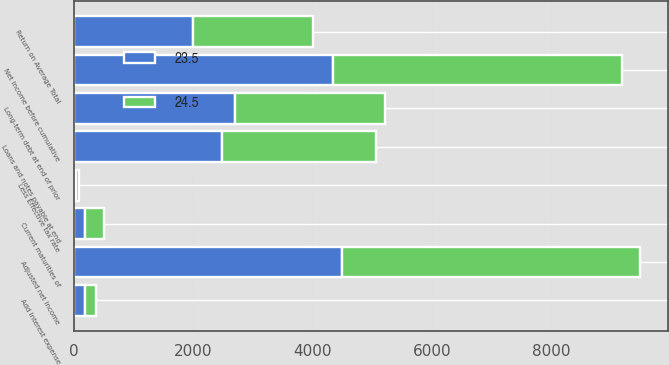Convert chart to OTSL. <chart><loc_0><loc_0><loc_500><loc_500><stacked_bar_chart><ecel><fcel>Return on Average Total<fcel>Net income before cumulative<fcel>Add Interest expense<fcel>Less Effective tax rate<fcel>Adjusted net income<fcel>Loans and notes payable at end<fcel>Current maturities of<fcel>Long-term debt at end of prior<nl><fcel>24.5<fcel>2004<fcel>4847<fcel>196<fcel>43<fcel>5000<fcel>2583<fcel>323<fcel>2517<nl><fcel>23.5<fcel>2003<fcel>4347<fcel>178<fcel>37<fcel>4488<fcel>2475<fcel>180<fcel>2701<nl></chart> 